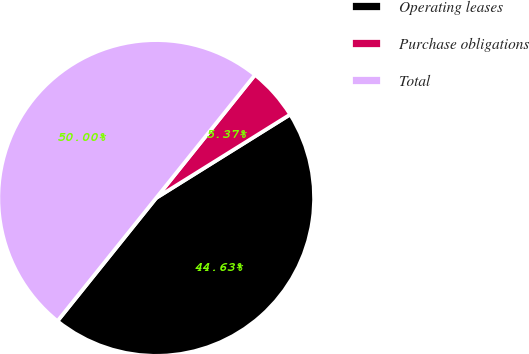<chart> <loc_0><loc_0><loc_500><loc_500><pie_chart><fcel>Operating leases<fcel>Purchase obligations<fcel>Total<nl><fcel>44.63%<fcel>5.37%<fcel>50.0%<nl></chart> 